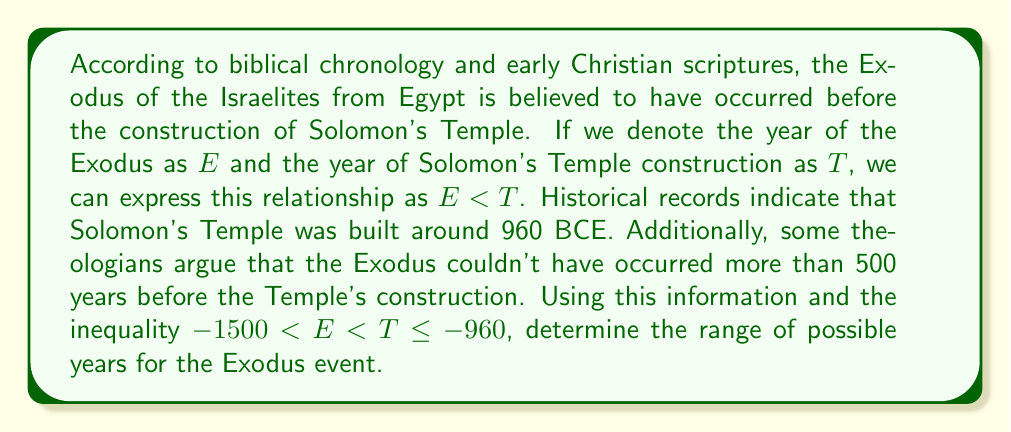Show me your answer to this math problem. To solve this problem, we need to combine the given inequalities and interpret them in the context of biblical chronology:

1. We start with the given inequality: $-1500 < E < T \leq -960$

2. We're told that the Exodus couldn't have occurred more than 500 years before the Temple's construction. We can express this as:
   $T - 500 \leq E$

3. Combining these inequalities:
   $\max(-1500, T - 500) < E < T \leq -960$

4. Since $T \leq -960$, the earliest possible date for $E$ would be:
   $-960 - 500 = -1460$

5. Therefore, we can simplify our inequality to:
   $-1460 < E < -960$

6. In terms of BCE dates, this translates to:
   1460 BCE $>$ Exodus year $>$ 960 BCE

This range aligns with many theological interpretations of early Christian scriptures, placing the Exodus within the Late Bronze Age or early Iron Age, consistent with various biblical chronologies.
Answer: The range of possible years for the Exodus event is $(1460 \text{ BCE}, 960 \text{ BCE})$, or mathematically expressed as $-1460 < E < -960$. 